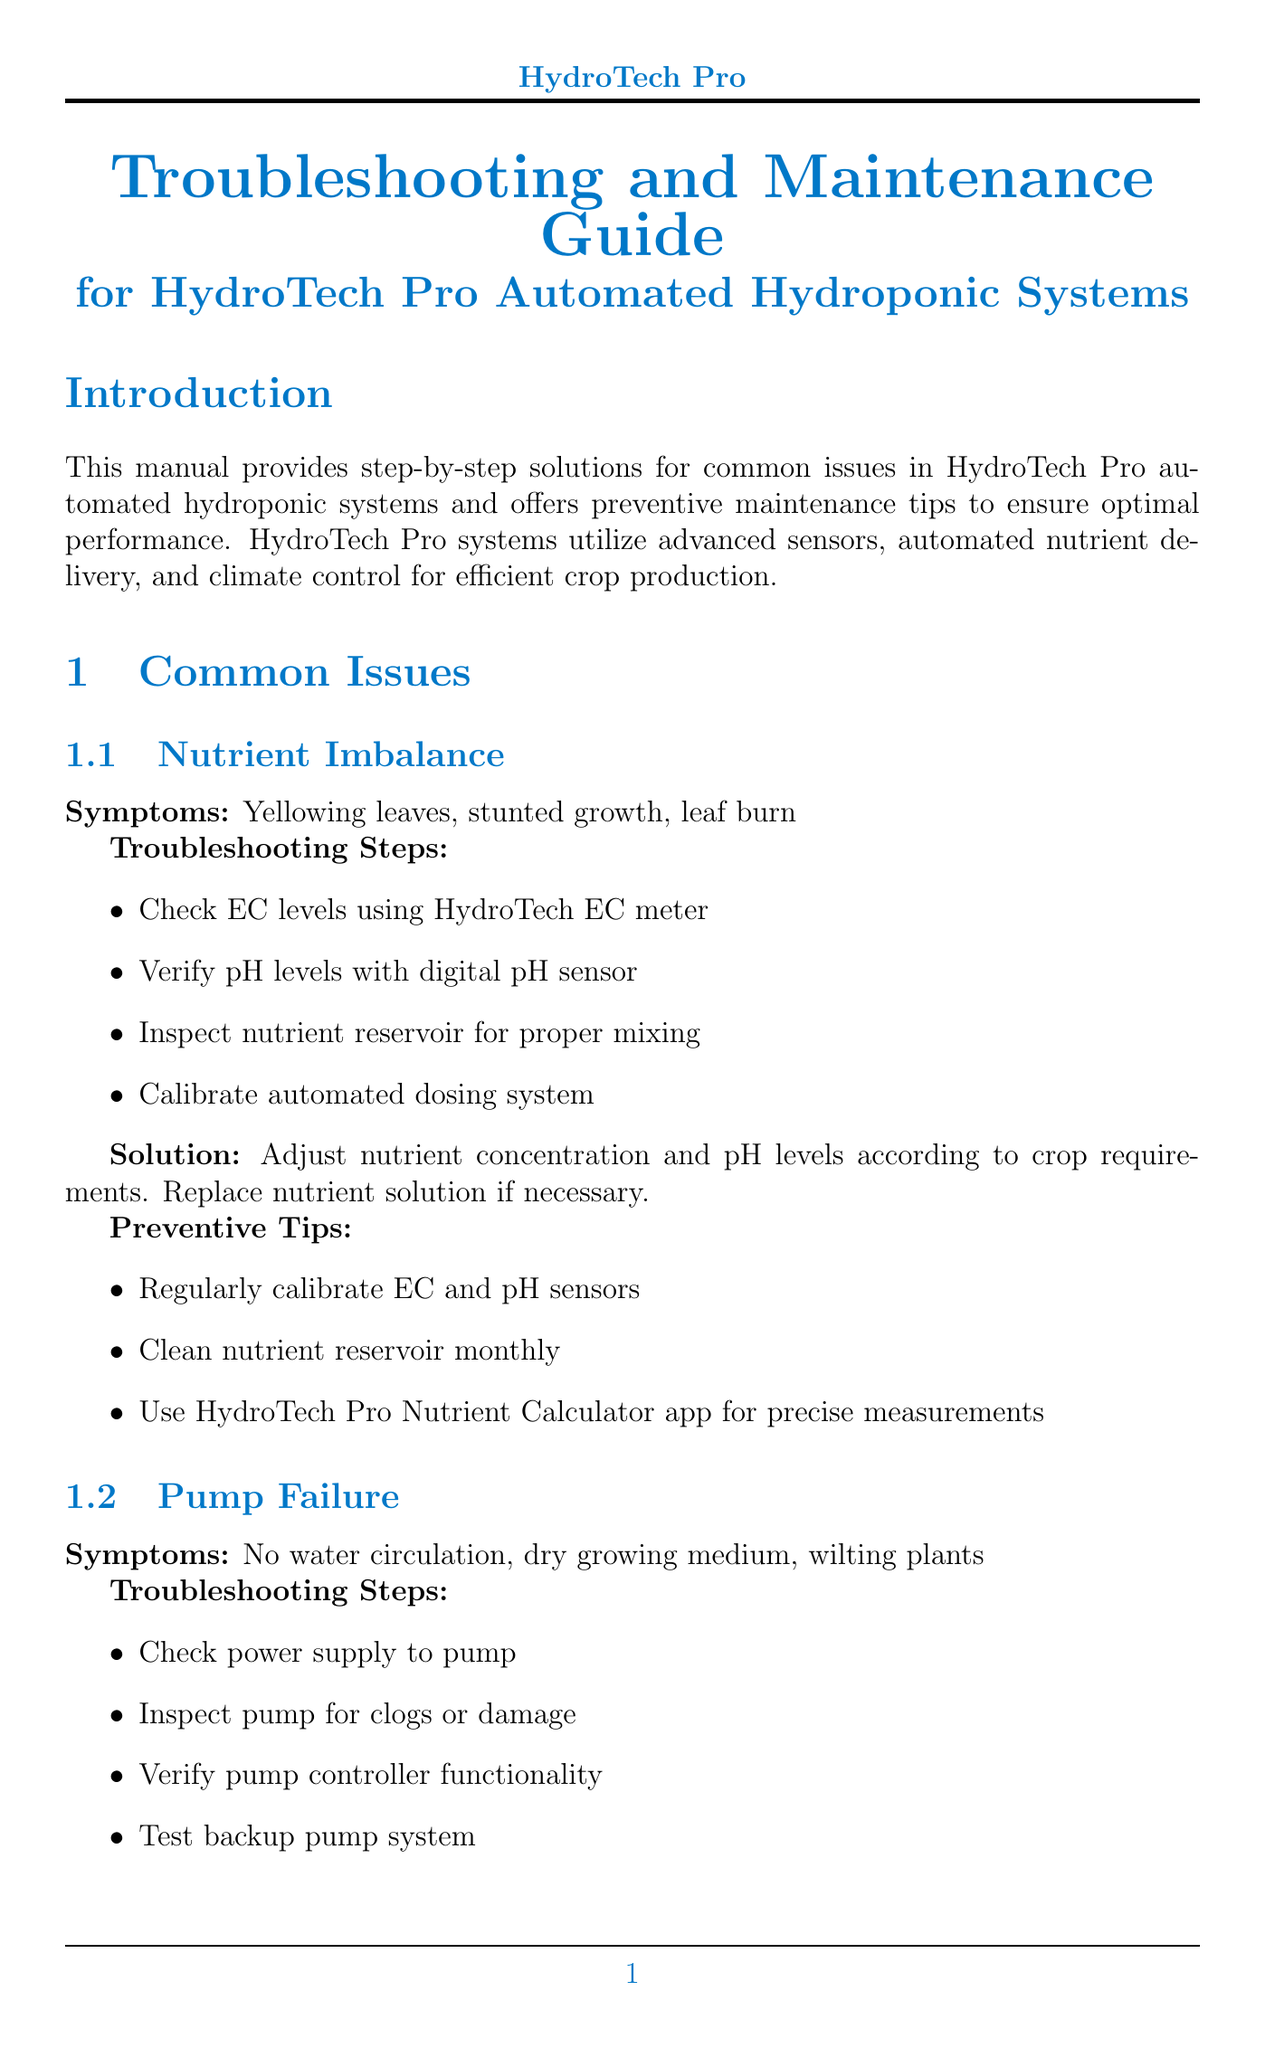What is the title of the manual? The title of the manual is stated in the document header.
Answer: Troubleshooting and Maintenance Guide for HydroTech Pro Automated Hydroponic Systems What are the symptoms of nutrient imbalance? Symptoms are listed under the common issue of nutrient imbalance.
Answer: Yellowing leaves, stunted growth, leaf burn Which model should be used to replace a faulty pump? The solution for pump failure specifies the model to use for replacement.
Answer: HydroTech Pro HP200 model How often should the nutrient reservoir be cleaned? Preventive tips specify a monthly cleaning frequency for the nutrient reservoir.
Answer: Monthly What contact phone number is provided for support? The support contact section mentions the phone number for support.
Answer: +1-800-HYDROTECH List one task for daily preventive maintenance. Daily tasks are listed under the preventive maintenance section; one task is specified.
Answer: Check system alerts on HydroTech Pro mobile app What is required to identify lighting system malfunctions? Troubleshooting steps for lighting system malfunction indicate what checks are necessary.
Answer: Check power connection to LED panels How frequently should UV sterilization bulbs be replaced? The quarterly tasks outline the replacement frequency for UV sterilization bulbs.
Answer: Quarterly 